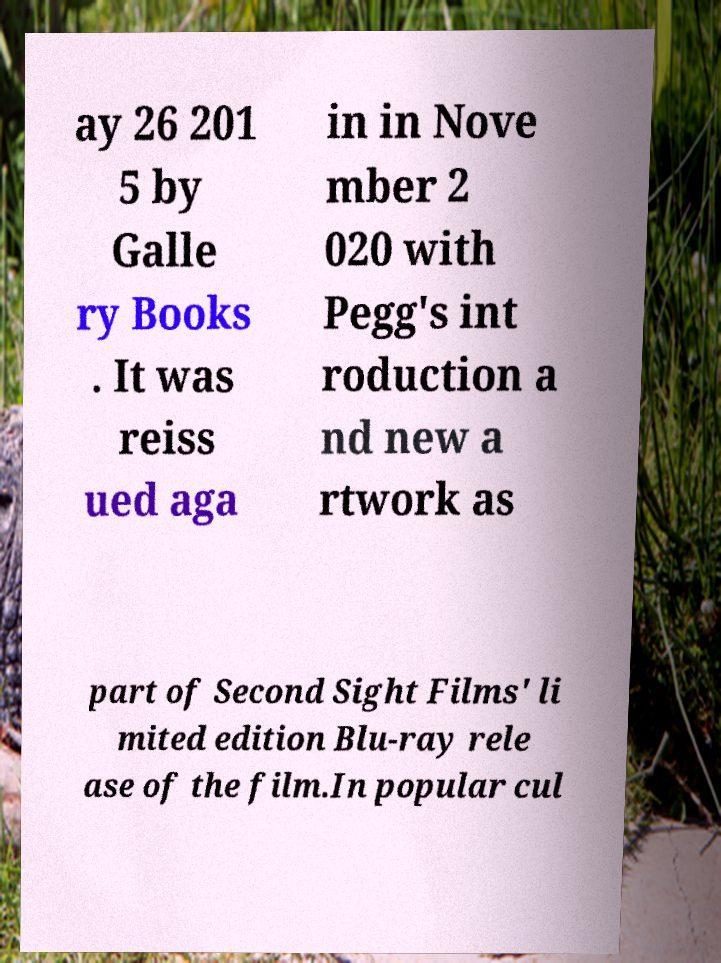I need the written content from this picture converted into text. Can you do that? ay 26 201 5 by Galle ry Books . It was reiss ued aga in in Nove mber 2 020 with Pegg's int roduction a nd new a rtwork as part of Second Sight Films' li mited edition Blu-ray rele ase of the film.In popular cul 